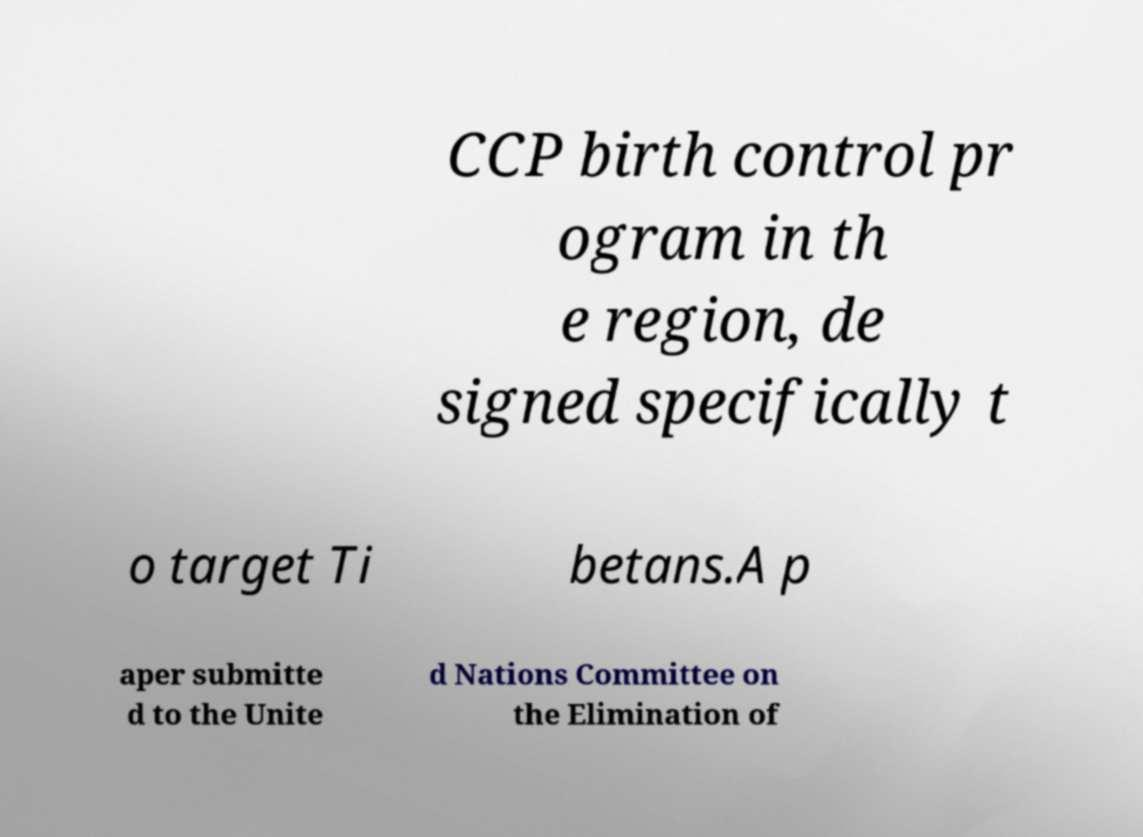I need the written content from this picture converted into text. Can you do that? CCP birth control pr ogram in th e region, de signed specifically t o target Ti betans.A p aper submitte d to the Unite d Nations Committee on the Elimination of 